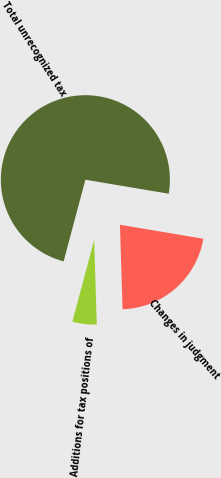Convert chart to OTSL. <chart><loc_0><loc_0><loc_500><loc_500><pie_chart><fcel>Total unrecognized tax<fcel>Additions for tax positions of<fcel>Changes in judgment<nl><fcel>73.5%<fcel>4.64%<fcel>21.86%<nl></chart> 